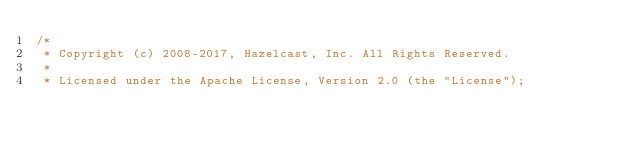<code> <loc_0><loc_0><loc_500><loc_500><_Java_>/*
 * Copyright (c) 2008-2017, Hazelcast, Inc. All Rights Reserved.
 *
 * Licensed under the Apache License, Version 2.0 (the "License");</code> 